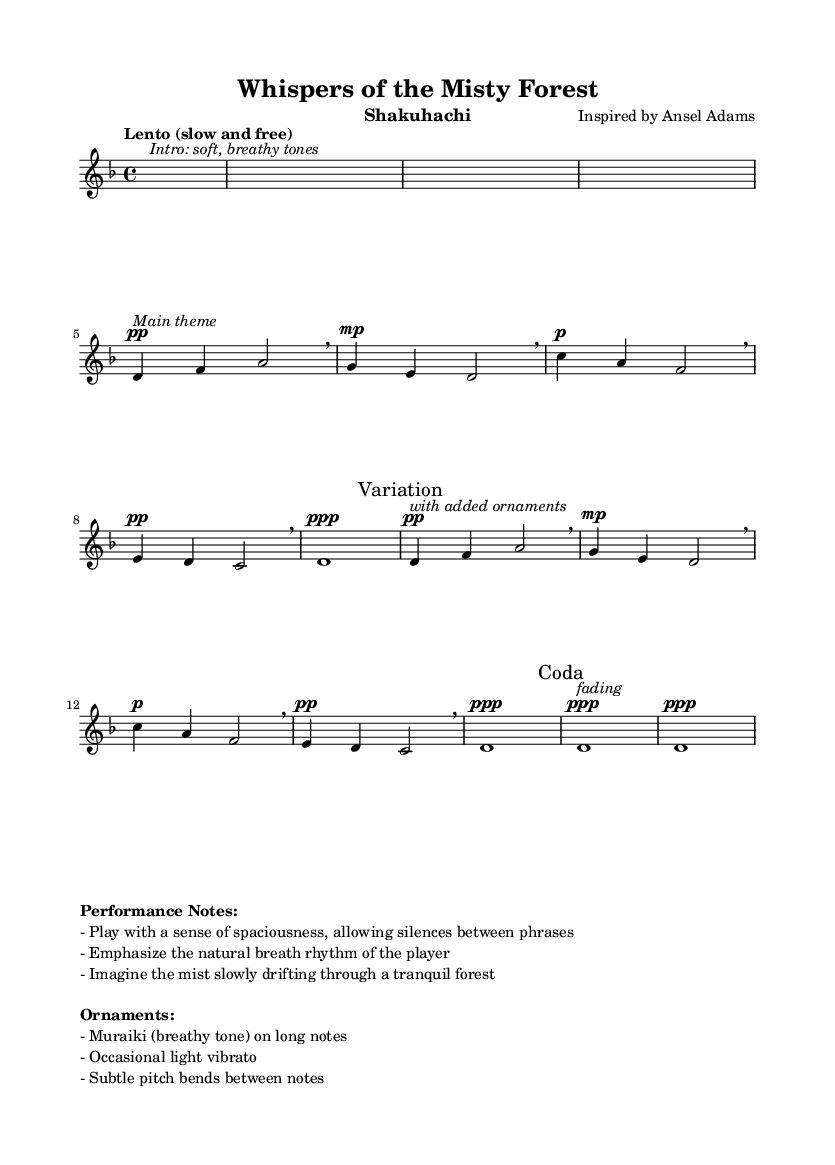What is the key signature of this music? The key signature is identified by looking for any sharps or flats at the beginning of the staff. In this case, the presence of a flat symbol indicates that the key is D minor, which has one flat.
Answer: D minor What is the time signature of this piece? The time signature is found at the beginning of the score, displayed as a fraction. Here, it is 4/4, which means there are four beats per measure and that the quarter note gets one beat.
Answer: 4/4 What is the tempo marking for this composition? The tempo marking is written at the beginning of the score. In this case, the words "Lento (slow and free)" indicate the desired tempo, suggesting a relaxed and unhurried pace.
Answer: Lento How many measures are there in the main theme? To find the number of measures in the main theme, we can count the number of vertical bars on the staff that denote the end of each measure. There are eight measures within the section marked as the main theme.
Answer: 8 What ornamentation techniques are suggested in the performance notes? The performance notes provide several techniques related to ornamentation. The notes specifically mention Muraiki (breathy tone) on long notes, light vibrato, and subtle pitch bends between notes.
Answer: Muraiki, vibrato, pitch bends What is the overall dynamic direction for the coda section? The coda section is marked with the dynamic indication of "ppp", which means to play very softly. This is noted at the beginning of the coda part in the music.
Answer: ppp Which musical instrument is this composition written for? The instrument is indicated in the header section of the score. It specifies that the piece is composed for the shakuhachi, which is a traditional Japanese bamboo flute.
Answer: Shakuhachi 